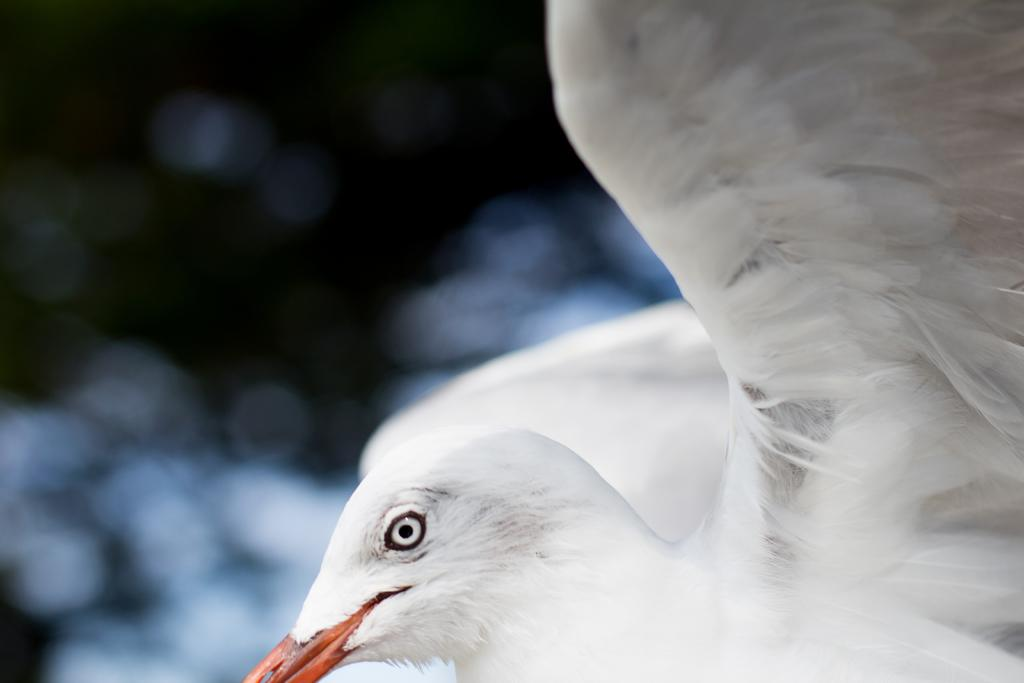What type of animal can be seen in the image? There is a white color bird in the image. Can you describe the background of the image? The background of the image is blurry. What is the farmer thinking about while holding the bird in the image? There is no farmer present in the image, and therefore no thoughts can be attributed to them. 